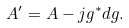<formula> <loc_0><loc_0><loc_500><loc_500>A ^ { \prime } = A - j g ^ { * } d g .</formula> 